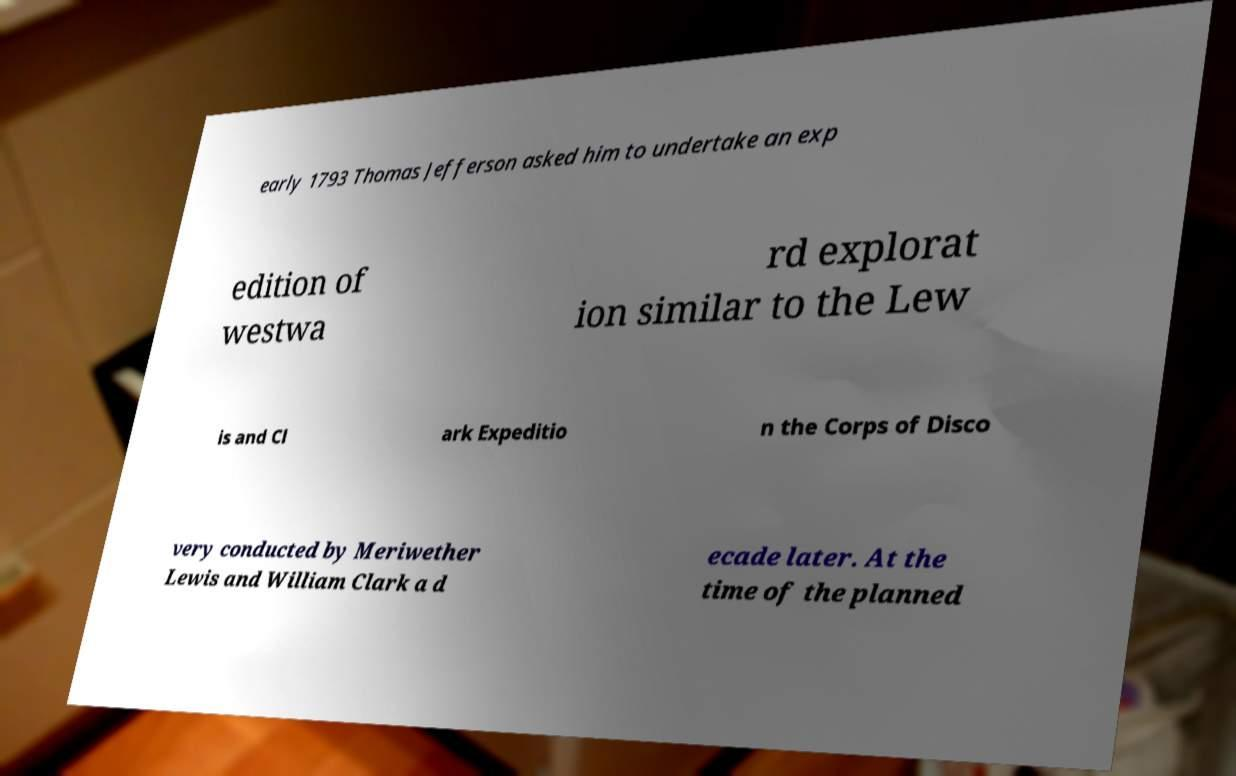Could you extract and type out the text from this image? early 1793 Thomas Jefferson asked him to undertake an exp edition of westwa rd explorat ion similar to the Lew is and Cl ark Expeditio n the Corps of Disco very conducted by Meriwether Lewis and William Clark a d ecade later. At the time of the planned 